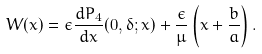<formula> <loc_0><loc_0><loc_500><loc_500>W ( x ) = \epsilon \frac { d P _ { 4 } } { d x } ( 0 , \delta ; x ) + \frac { \epsilon } { \mu } \left ( x + \frac { b } { a } \right ) .</formula> 